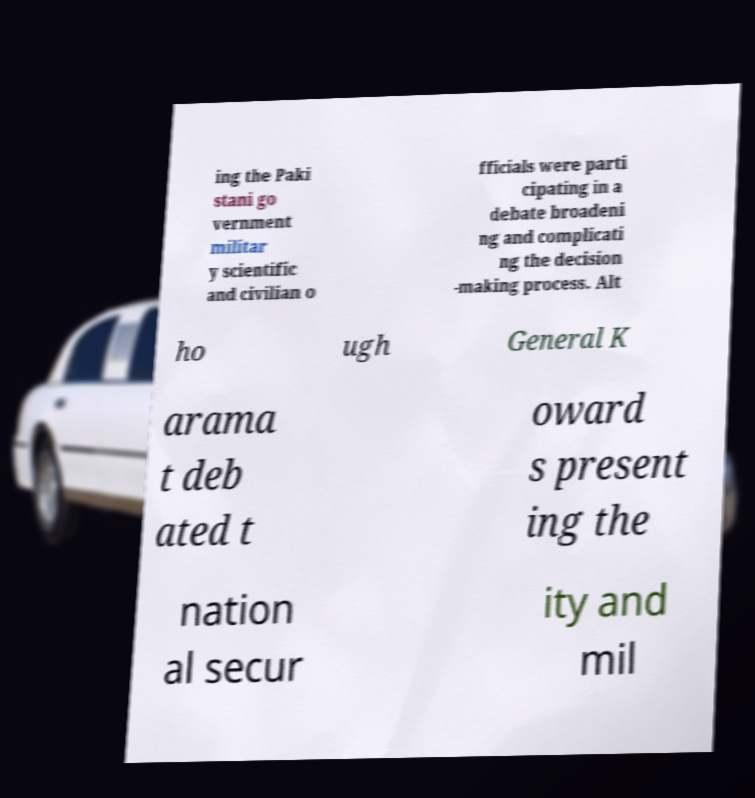Could you assist in decoding the text presented in this image and type it out clearly? ing the Paki stani go vernment militar y scientific and civilian o fficials were parti cipating in a debate broadeni ng and complicati ng the decision -making process. Alt ho ugh General K arama t deb ated t oward s present ing the nation al secur ity and mil 